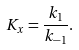Convert formula to latex. <formula><loc_0><loc_0><loc_500><loc_500>K _ { x } = \frac { k _ { 1 } } { k _ { - 1 } } .</formula> 